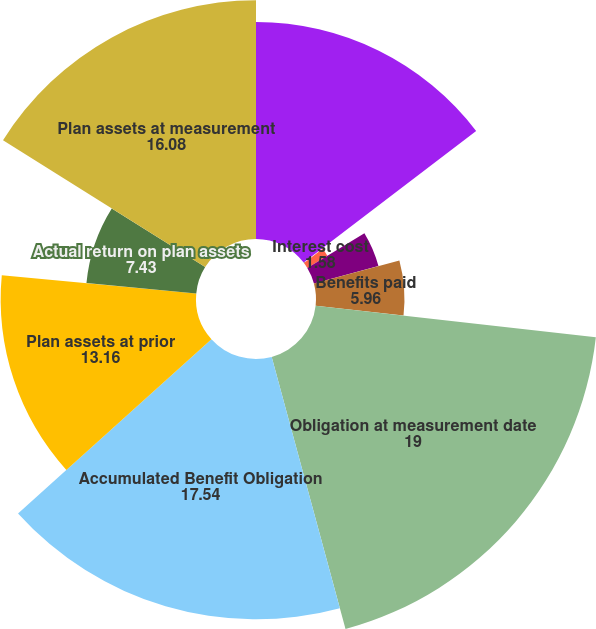<chart> <loc_0><loc_0><loc_500><loc_500><pie_chart><fcel>Obligation at prior<fcel>Service cost<fcel>Interest cost<fcel>Actuarial loss<fcel>Benefits paid<fcel>Obligation at measurement date<fcel>Accumulated Benefit Obligation<fcel>Plan assets at prior<fcel>Actual return on plan assets<fcel>Plan assets at measurement<nl><fcel>14.62%<fcel>0.12%<fcel>1.58%<fcel>4.5%<fcel>5.96%<fcel>19.0%<fcel>17.54%<fcel>13.16%<fcel>7.43%<fcel>16.08%<nl></chart> 